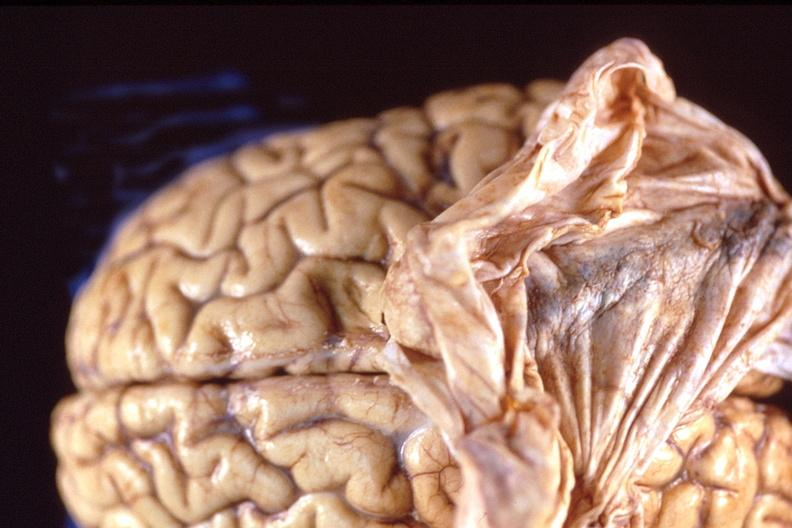s nervous present?
Answer the question using a single word or phrase. Yes 